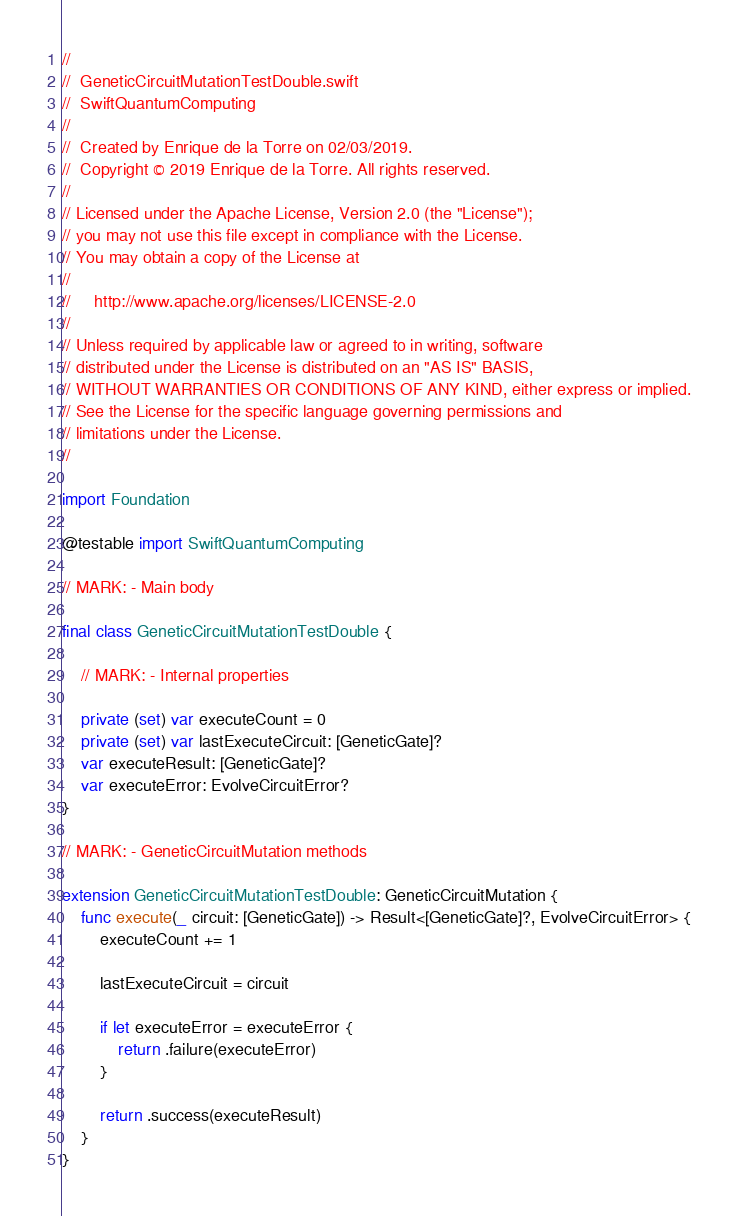<code> <loc_0><loc_0><loc_500><loc_500><_Swift_>//
//  GeneticCircuitMutationTestDouble.swift
//  SwiftQuantumComputing
//
//  Created by Enrique de la Torre on 02/03/2019.
//  Copyright © 2019 Enrique de la Torre. All rights reserved.
//
// Licensed under the Apache License, Version 2.0 (the "License");
// you may not use this file except in compliance with the License.
// You may obtain a copy of the License at
//
//     http://www.apache.org/licenses/LICENSE-2.0
//
// Unless required by applicable law or agreed to in writing, software
// distributed under the License is distributed on an "AS IS" BASIS,
// WITHOUT WARRANTIES OR CONDITIONS OF ANY KIND, either express or implied.
// See the License for the specific language governing permissions and
// limitations under the License.
//

import Foundation

@testable import SwiftQuantumComputing

// MARK: - Main body

final class GeneticCircuitMutationTestDouble {

    // MARK: - Internal properties

    private (set) var executeCount = 0
    private (set) var lastExecuteCircuit: [GeneticGate]?
    var executeResult: [GeneticGate]?
    var executeError: EvolveCircuitError?
}

// MARK: - GeneticCircuitMutation methods

extension GeneticCircuitMutationTestDouble: GeneticCircuitMutation {
    func execute(_ circuit: [GeneticGate]) -> Result<[GeneticGate]?, EvolveCircuitError> {
        executeCount += 1

        lastExecuteCircuit = circuit

        if let executeError = executeError {
            return .failure(executeError)
        }

        return .success(executeResult)
    }
}
</code> 